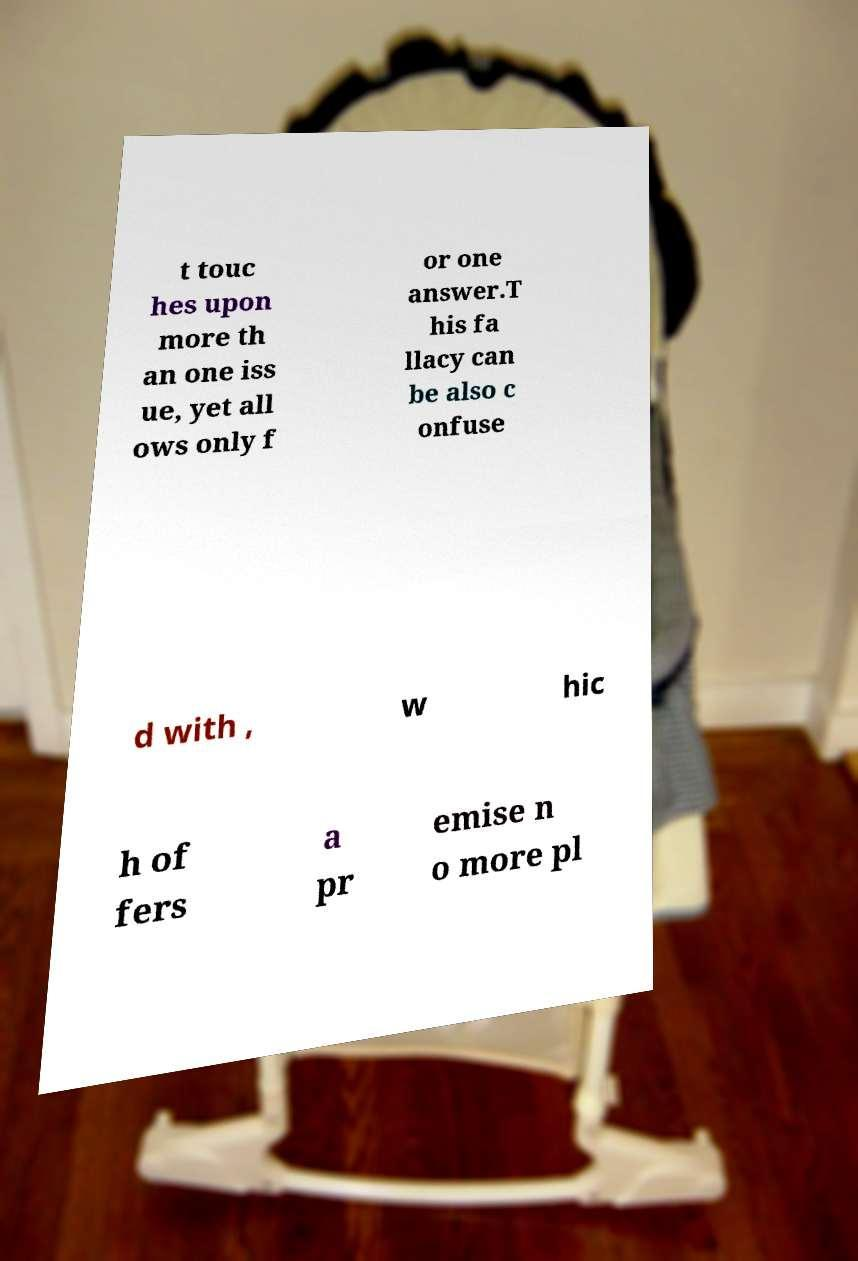Please identify and transcribe the text found in this image. t touc hes upon more th an one iss ue, yet all ows only f or one answer.T his fa llacy can be also c onfuse d with , w hic h of fers a pr emise n o more pl 